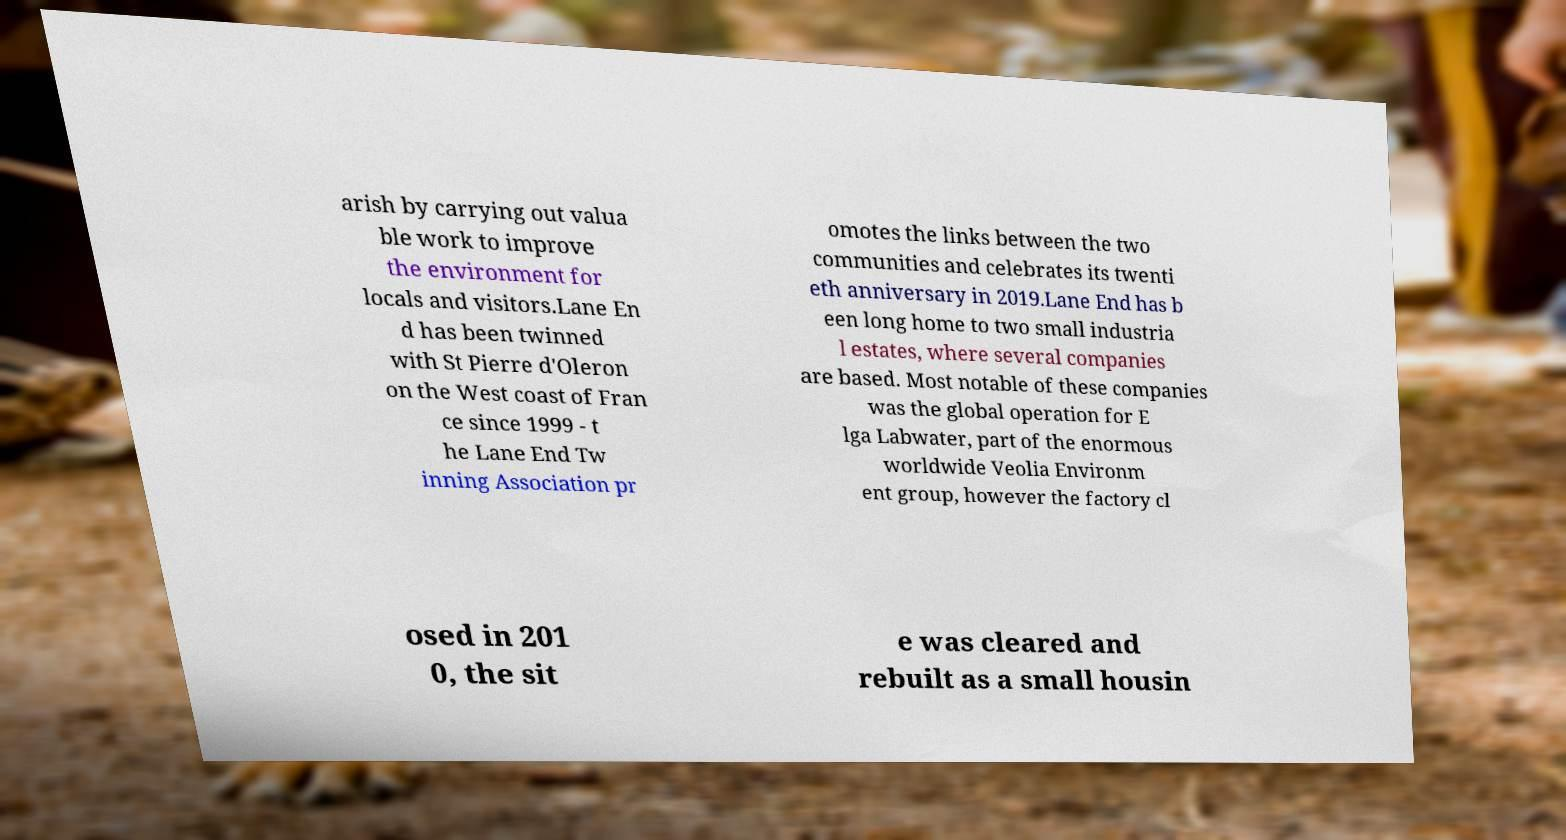Please read and relay the text visible in this image. What does it say? arish by carrying out valua ble work to improve the environment for locals and visitors.Lane En d has been twinned with St Pierre d'Oleron on the West coast of Fran ce since 1999 - t he Lane End Tw inning Association pr omotes the links between the two communities and celebrates its twenti eth anniversary in 2019.Lane End has b een long home to two small industria l estates, where several companies are based. Most notable of these companies was the global operation for E lga Labwater, part of the enormous worldwide Veolia Environm ent group, however the factory cl osed in 201 0, the sit e was cleared and rebuilt as a small housin 